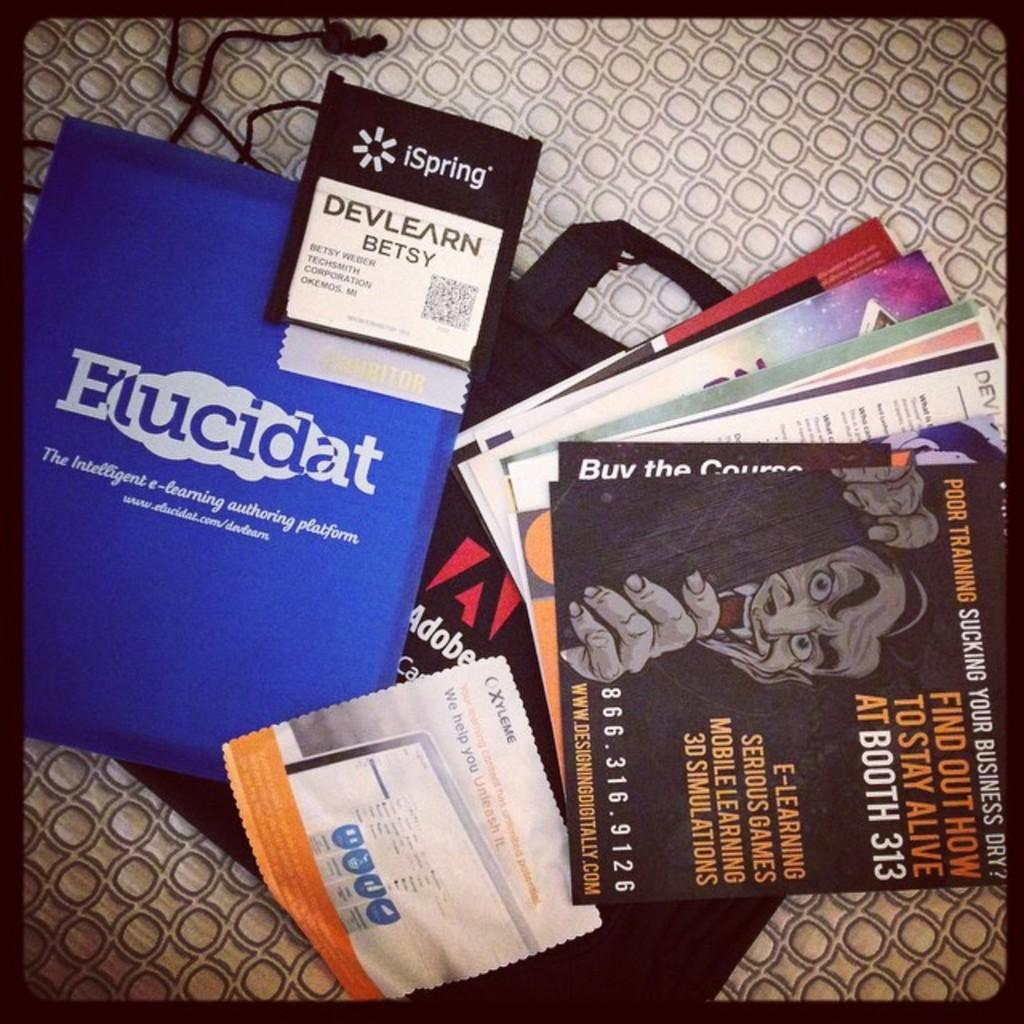<image>
Describe the image concisely. A surface with a lot of pamphlets on it with one that says Elucidat 